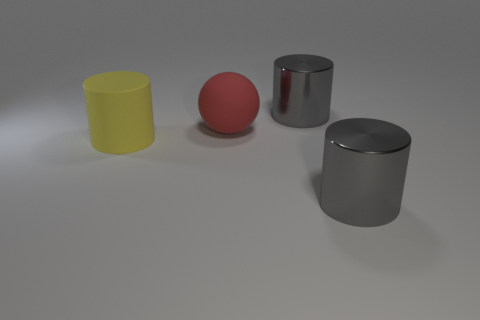The metallic object right of the shiny object behind the yellow matte cylinder is what color?
Offer a very short reply. Gray. Is the material of the big sphere the same as the large gray object that is in front of the red matte thing?
Ensure brevity in your answer.  No. There is a thing behind the large red thing; what is its material?
Keep it short and to the point. Metal. Is the number of red rubber objects on the right side of the ball the same as the number of big rubber balls?
Keep it short and to the point. No. Is there any other thing that has the same size as the yellow matte cylinder?
Your response must be concise. Yes. What material is the big gray cylinder that is behind the big metallic cylinder in front of the big red rubber object?
Offer a terse response. Metal. Is the number of big rubber balls behind the yellow matte thing less than the number of small purple blocks?
Offer a terse response. No. What size is the metal thing in front of the large yellow rubber object?
Your answer should be very brief. Large. How many other matte balls have the same color as the rubber sphere?
Give a very brief answer. 0. Is there any other thing that is the same shape as the big yellow thing?
Give a very brief answer. Yes. 